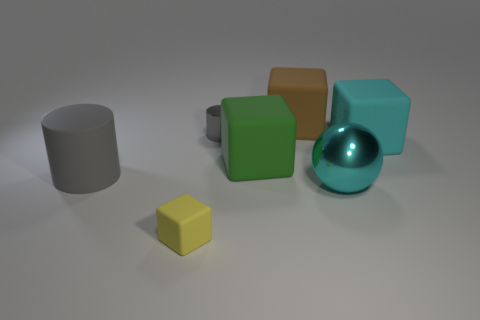Add 3 tiny yellow things. How many objects exist? 10 Subtract all balls. How many objects are left? 6 Subtract all cylinders. Subtract all yellow objects. How many objects are left? 4 Add 5 green rubber things. How many green rubber things are left? 6 Add 3 green cubes. How many green cubes exist? 4 Subtract 0 yellow balls. How many objects are left? 7 